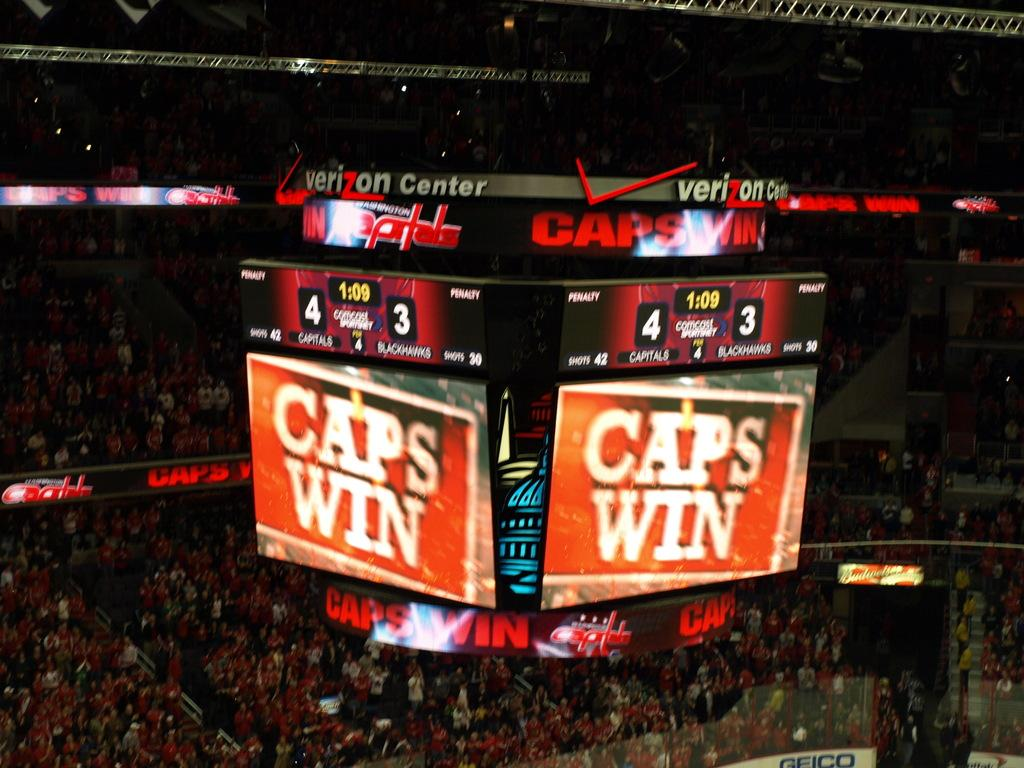<image>
Render a clear and concise summary of the photo. A scoreboard with Verizon advertising that says Caps win on the monitor. 